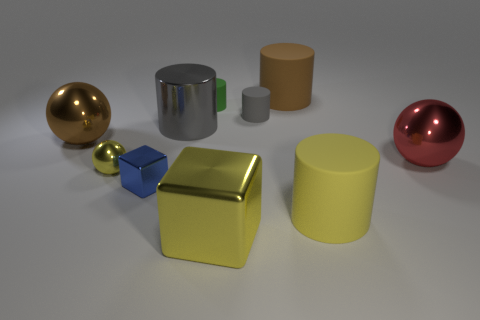Subtract all yellow cylinders. How many cylinders are left? 4 Subtract all big yellow rubber cylinders. How many cylinders are left? 4 Subtract all green cylinders. Subtract all green spheres. How many cylinders are left? 4 Subtract all spheres. How many objects are left? 7 Add 7 big yellow cubes. How many big yellow cubes exist? 8 Subtract 0 purple cylinders. How many objects are left? 10 Subtract all brown shiny objects. Subtract all large brown objects. How many objects are left? 7 Add 2 large yellow metallic things. How many large yellow metallic things are left? 3 